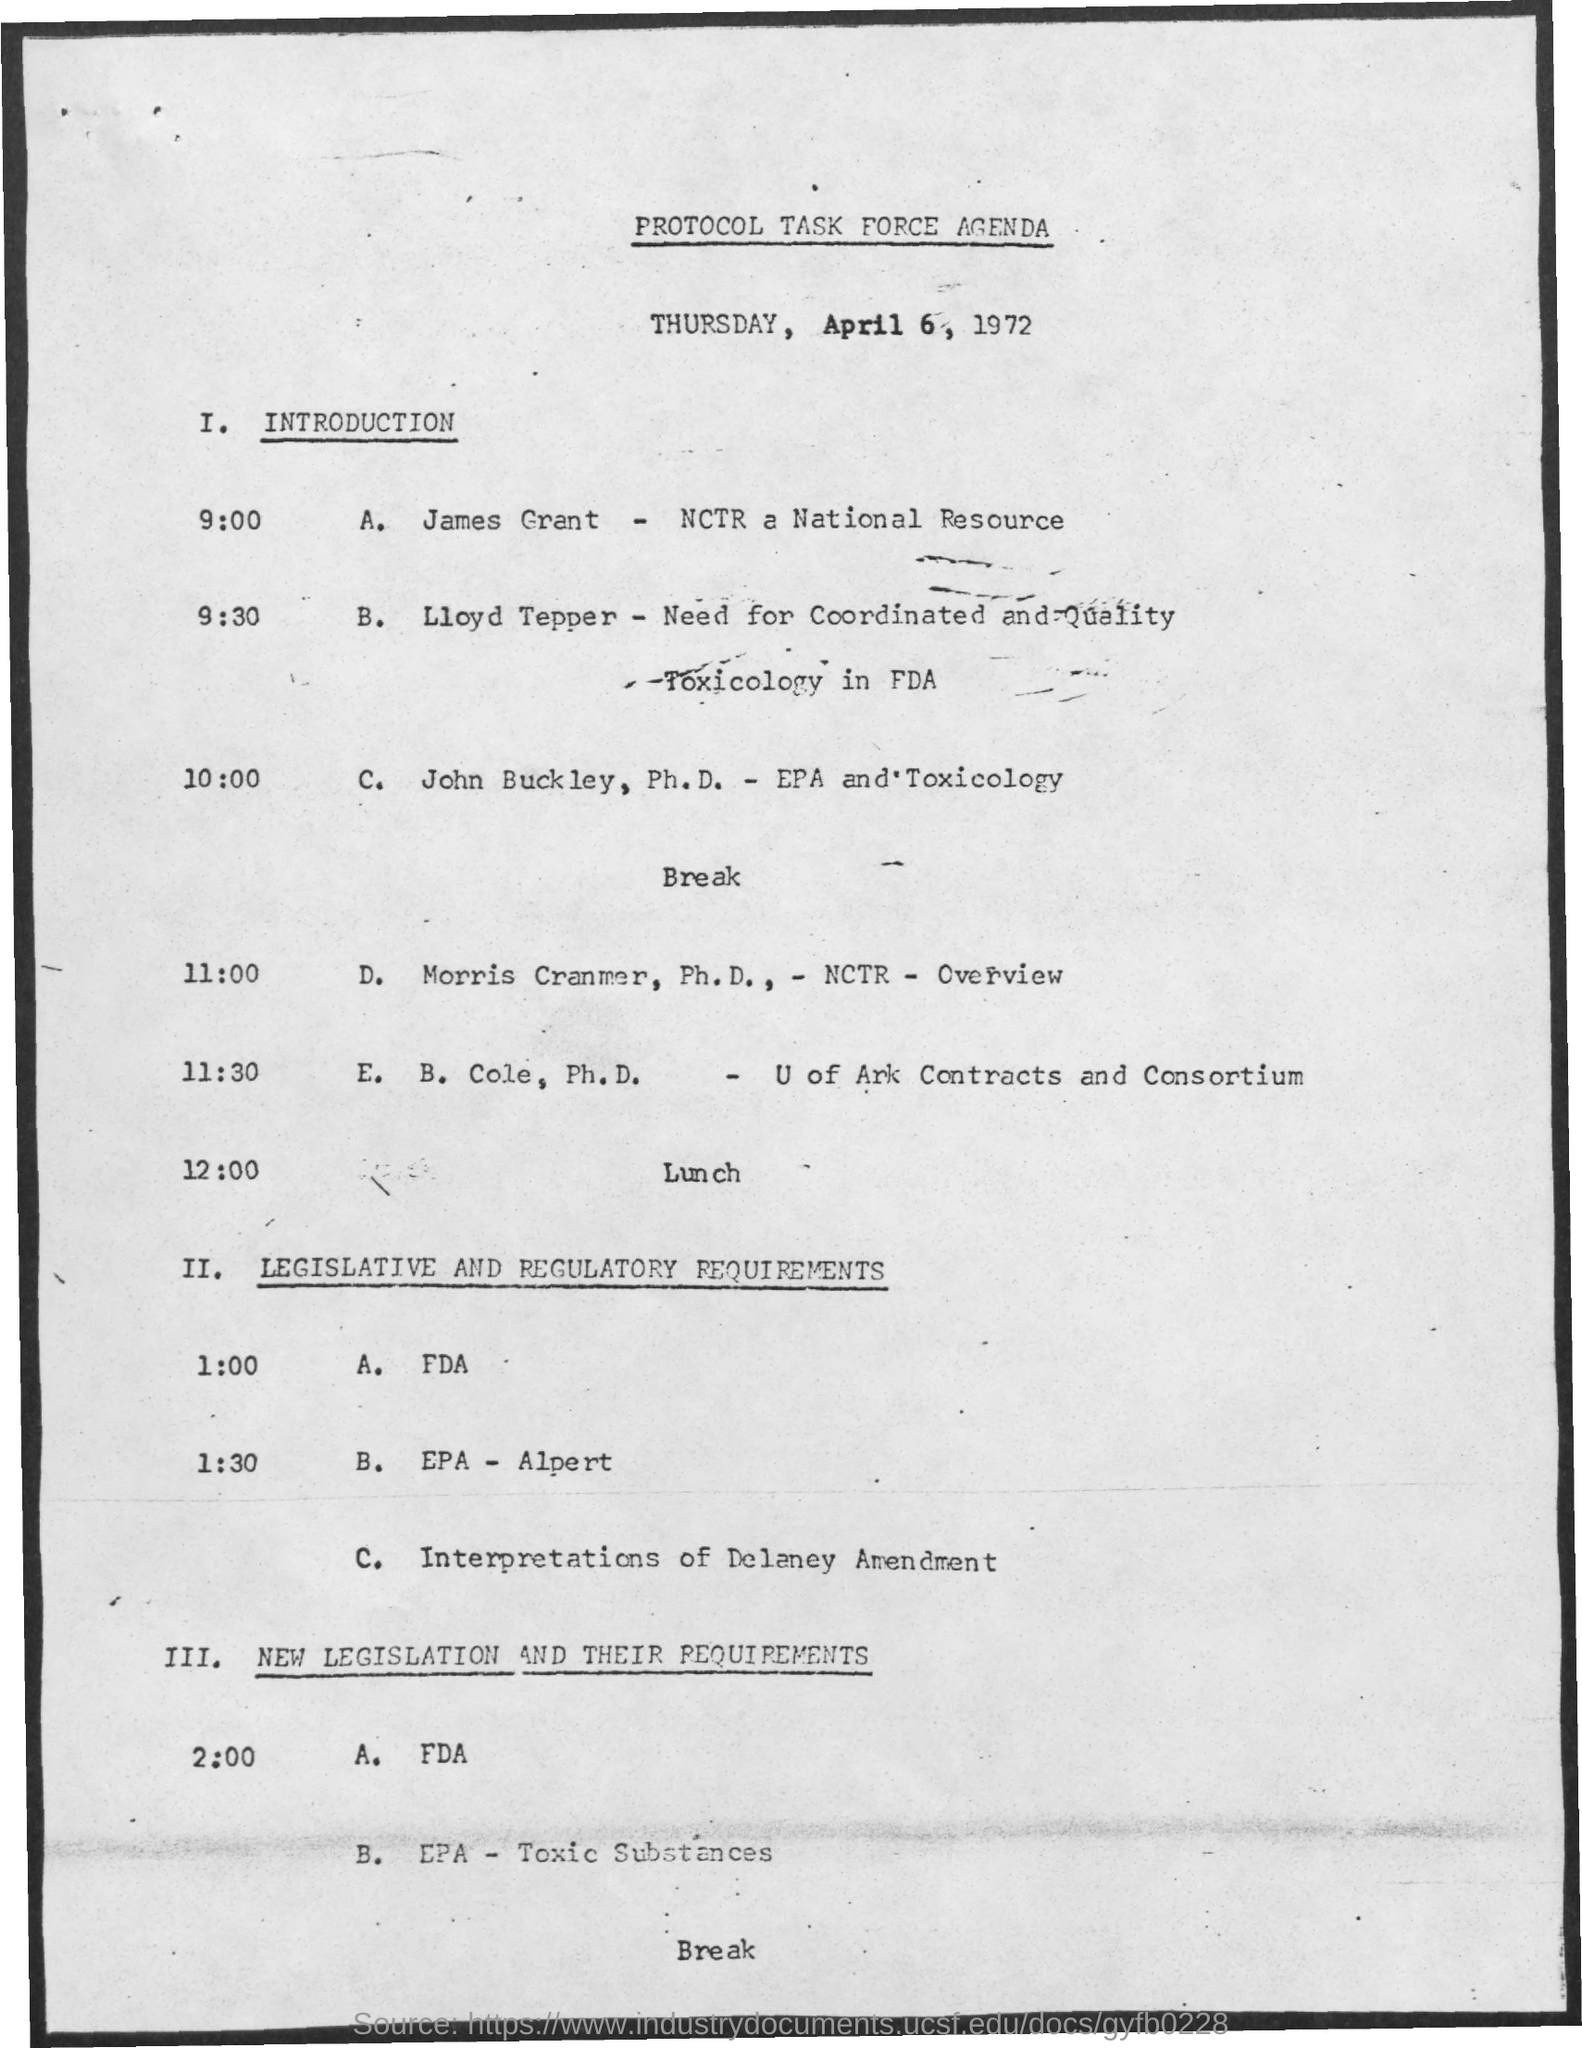List a handful of essential elements in this visual. The date mentioned in the document is April 6, 1972. 